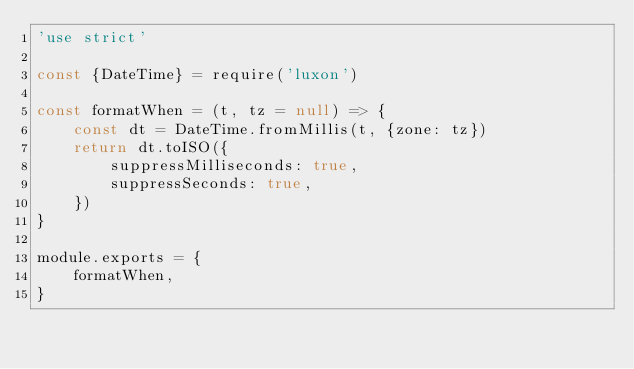<code> <loc_0><loc_0><loc_500><loc_500><_JavaScript_>'use strict'

const {DateTime} = require('luxon')

const formatWhen = (t, tz = null) => {
	const dt = DateTime.fromMillis(t, {zone: tz})
	return dt.toISO({
		suppressMilliseconds: true,
		suppressSeconds: true,
	})
}

module.exports = {
	formatWhen,
}
</code> 